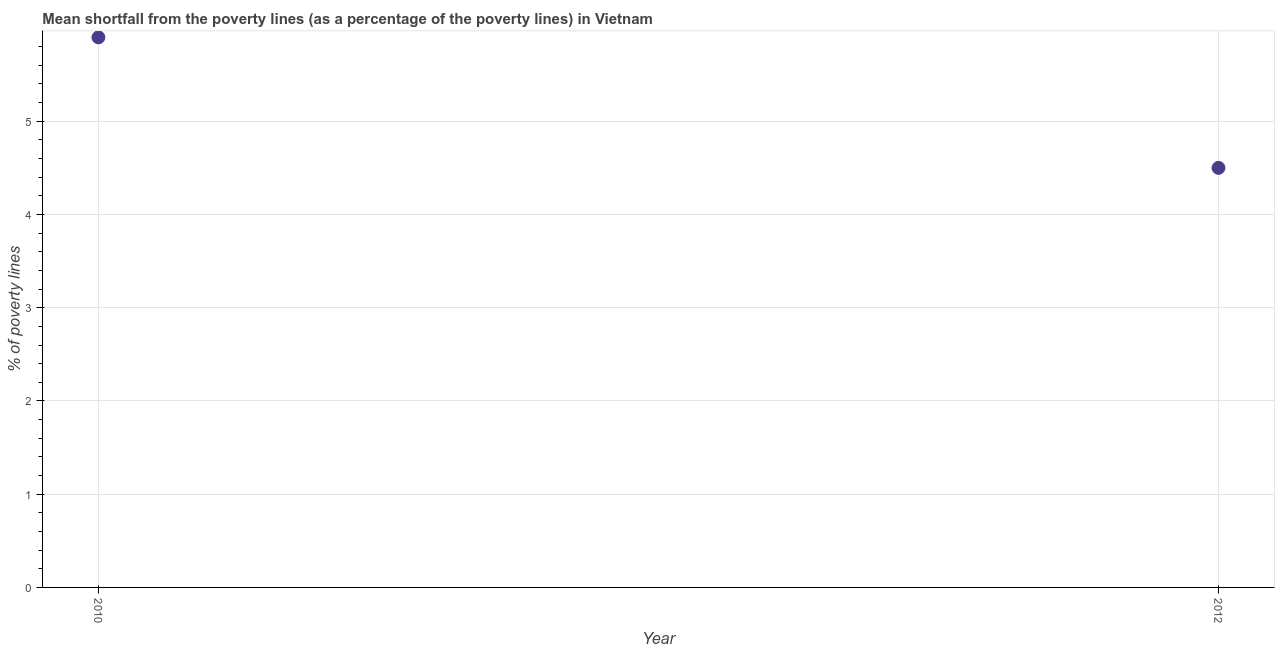What is the poverty gap at national poverty lines in 2010?
Make the answer very short. 5.9. Across all years, what is the maximum poverty gap at national poverty lines?
Give a very brief answer. 5.9. Across all years, what is the minimum poverty gap at national poverty lines?
Your answer should be compact. 4.5. In which year was the poverty gap at national poverty lines minimum?
Provide a succinct answer. 2012. What is the sum of the poverty gap at national poverty lines?
Your response must be concise. 10.4. What is the difference between the poverty gap at national poverty lines in 2010 and 2012?
Keep it short and to the point. 1.4. Do a majority of the years between 2010 and 2012 (inclusive) have poverty gap at national poverty lines greater than 2.6 %?
Provide a short and direct response. Yes. What is the ratio of the poverty gap at national poverty lines in 2010 to that in 2012?
Give a very brief answer. 1.31. In how many years, is the poverty gap at national poverty lines greater than the average poverty gap at national poverty lines taken over all years?
Your answer should be very brief. 1. Does the poverty gap at national poverty lines monotonically increase over the years?
Make the answer very short. No. How many years are there in the graph?
Offer a very short reply. 2. What is the difference between two consecutive major ticks on the Y-axis?
Offer a very short reply. 1. Are the values on the major ticks of Y-axis written in scientific E-notation?
Your answer should be very brief. No. Does the graph contain any zero values?
Your answer should be very brief. No. What is the title of the graph?
Ensure brevity in your answer.  Mean shortfall from the poverty lines (as a percentage of the poverty lines) in Vietnam. What is the label or title of the Y-axis?
Your answer should be very brief. % of poverty lines. What is the % of poverty lines in 2012?
Your answer should be compact. 4.5. What is the difference between the % of poverty lines in 2010 and 2012?
Provide a succinct answer. 1.4. What is the ratio of the % of poverty lines in 2010 to that in 2012?
Ensure brevity in your answer.  1.31. 